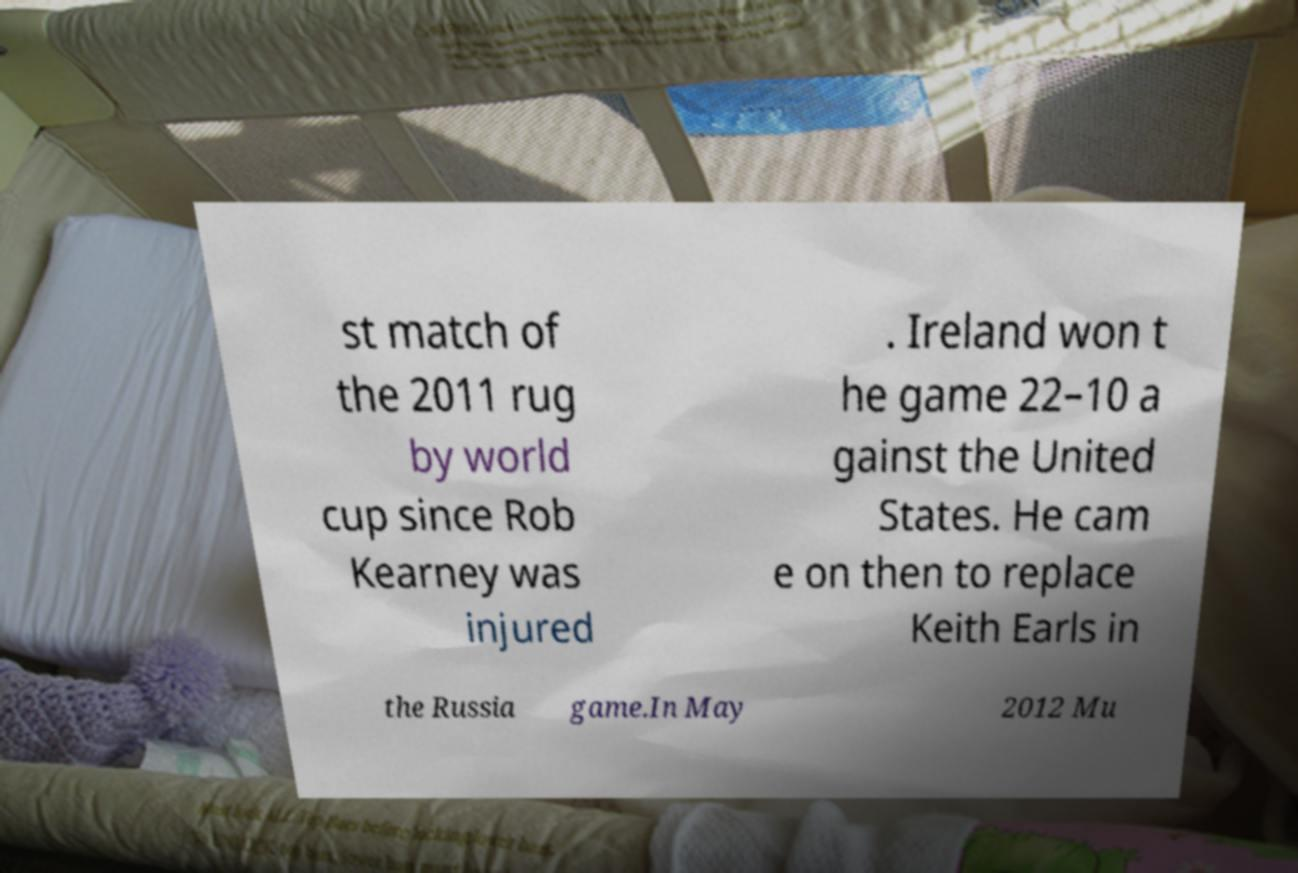Please identify and transcribe the text found in this image. st match of the 2011 rug by world cup since Rob Kearney was injured . Ireland won t he game 22–10 a gainst the United States. He cam e on then to replace Keith Earls in the Russia game.In May 2012 Mu 